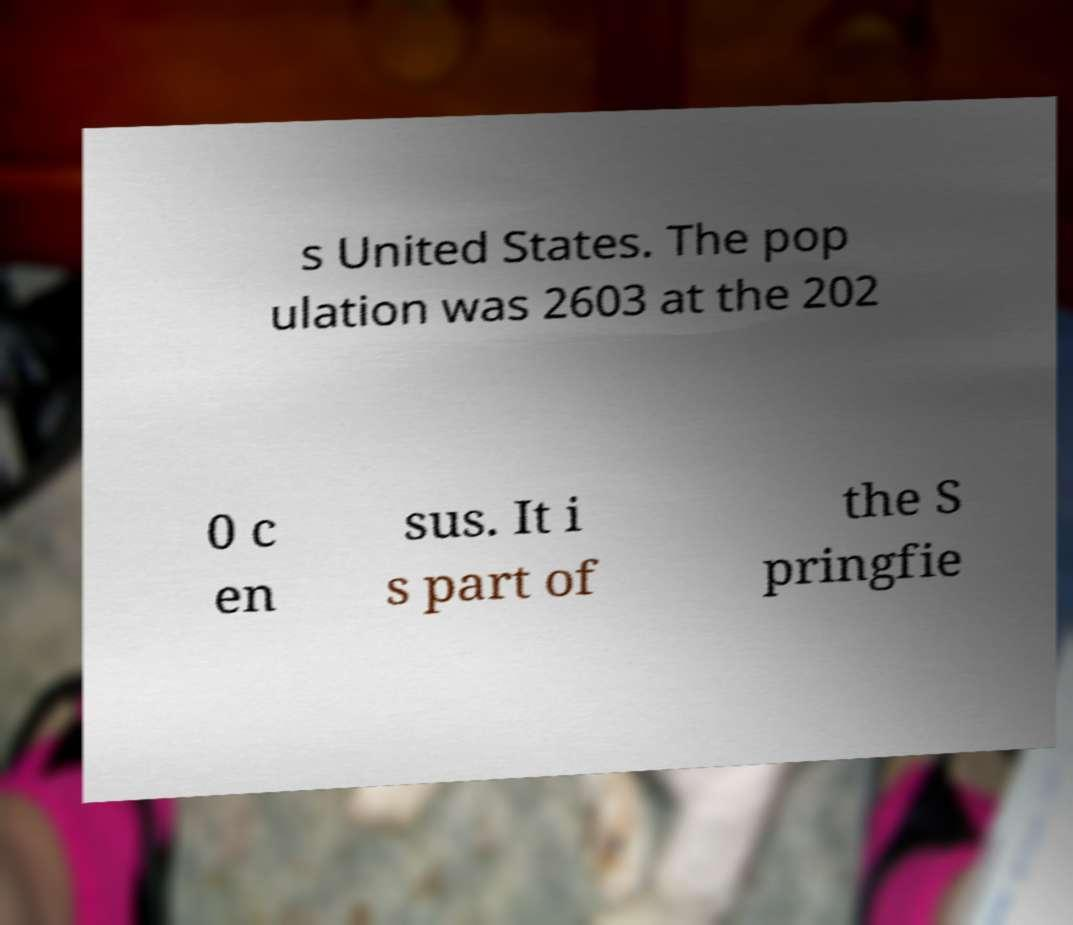What messages or text are displayed in this image? I need them in a readable, typed format. s United States. The pop ulation was 2603 at the 202 0 c en sus. It i s part of the S pringfie 